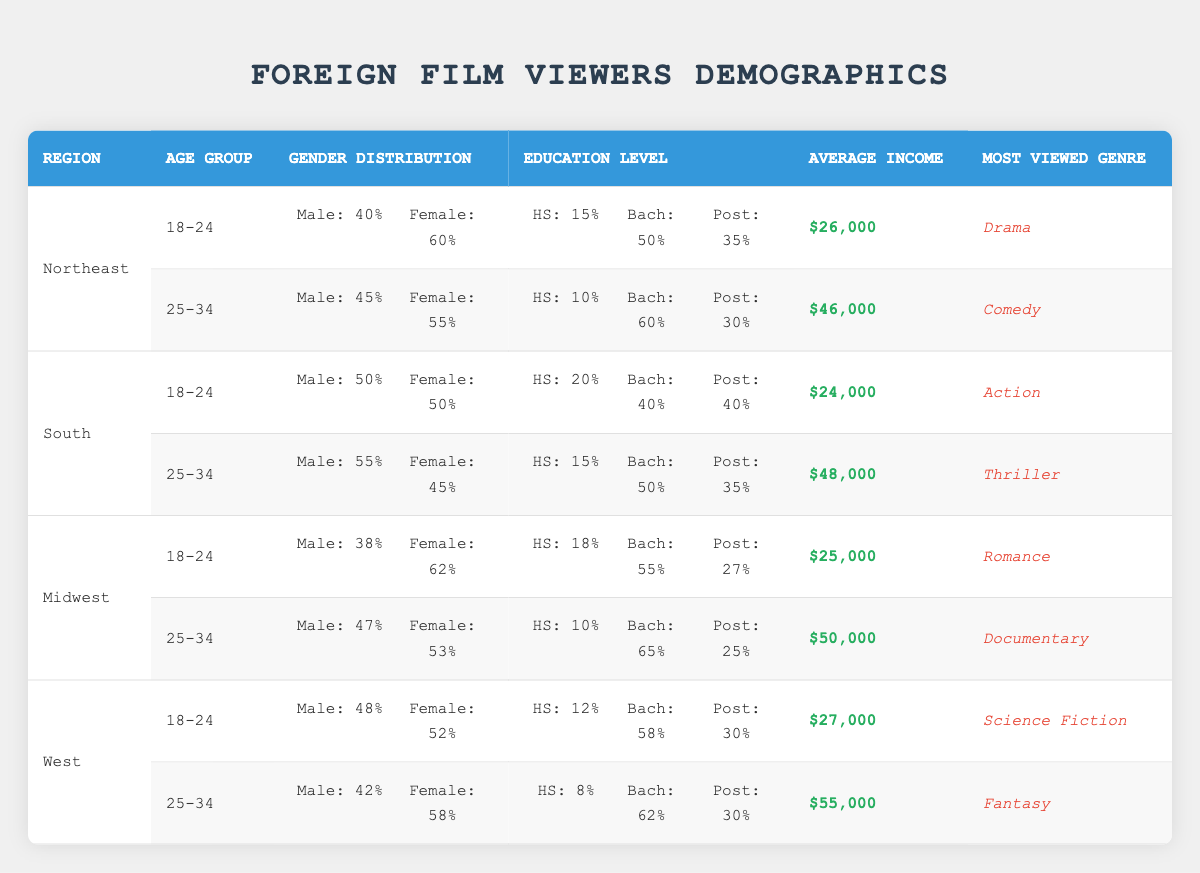What is the most viewed genre among foreign film viewers aged 18-24 in the Midwest? Looking at the Midwest region and the age group 18-24, the most viewed genre is Romance according to the data.
Answer: Romance What percentage of foreign film viewers aged 25-34 in the West are male? In the West, for the age group 25-34, the gender distribution shows that 42% of viewers are male.
Answer: 42% Which region has the highest average income for foreign film viewers aged 25-34? By comparing the average income for the 25-34 age group across all regions, the West has the highest average income at $55,000.
Answer: West What is the average income of foreign film viewers aged 18-24 in the South and Northeast combined? To find the average income for the 18-24 age group in both the South ($24,000) and Northeast ($26,000), sum them (24,000 + 26,000 = 50,000) and then divide by 2. Thus, the average is $25,000.
Answer: $25,000 True or False: The percentage of females among foreign film viewers aged 18-24 is equal in the South and Northeast. In the South, 50% of viewers aged 18-24 are female, while in the Northeast it's 60%, which shows they are not equal.
Answer: False How much higher is the average income of 25-34 year-old viewers in the Midwest compared to those in the Northeast? The average income for 25-34 year-olds in the Midwest is $50,000, while in the Northeast it’s $46,000. The difference is $50,000 - $46,000 = $4,000.
Answer: $4,000 What is the most common level of education for foreign film viewers aged 18-24 in the West? For viewers aged 18-24 in the West, the education level shows that 58% have a bachelor's degree, making it the most common level of education.
Answer: Bachelor's Which age group in the South has a higher average income, and by how much? In the South, the average income for the 25-34 age group is $48,000, while the income for the 18-24 age group is $24,000. The difference is $48,000 - $24,000 = $24,000.
Answer: $24,000 Do more foreign film viewers in the Northeast aged 18-24 have a postgraduate education compared to those in the Midwest aged 25-34? In the Northeast, 35% of 18-24 year-old viewers have a postgraduate education, while in the Midwest, 25% of 25-34 year-old viewers have a postgraduate education. Thus, true.
Answer: True 